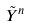<formula> <loc_0><loc_0><loc_500><loc_500>\tilde { Y } ^ { n }</formula> 